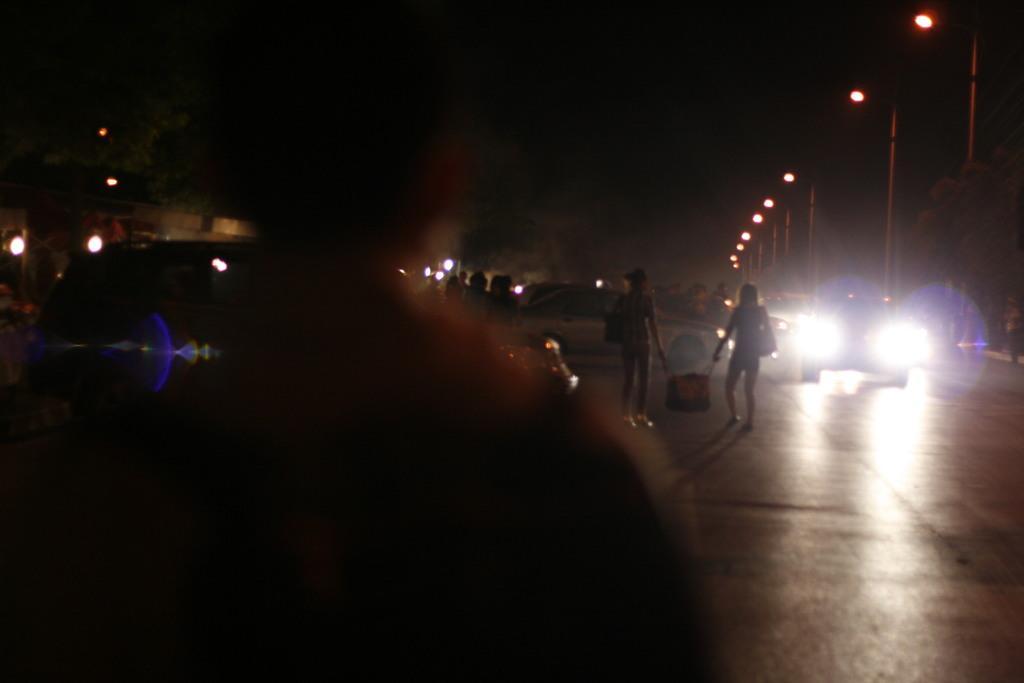How would you summarize this image in a sentence or two? This image is clicked on the road. In this image we can see two persons walking and they are holding a bag. On the right, there are vehicles along with street lights. On the left, the image is blurred. 